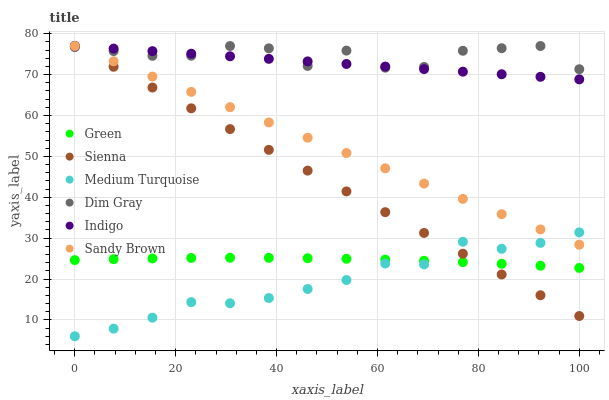Does Medium Turquoise have the minimum area under the curve?
Answer yes or no. Yes. Does Dim Gray have the maximum area under the curve?
Answer yes or no. Yes. Does Indigo have the minimum area under the curve?
Answer yes or no. No. Does Indigo have the maximum area under the curve?
Answer yes or no. No. Is Indigo the smoothest?
Answer yes or no. Yes. Is Dim Gray the roughest?
Answer yes or no. Yes. Is Sienna the smoothest?
Answer yes or no. No. Is Sienna the roughest?
Answer yes or no. No. Does Medium Turquoise have the lowest value?
Answer yes or no. Yes. Does Indigo have the lowest value?
Answer yes or no. No. Does Sandy Brown have the highest value?
Answer yes or no. Yes. Does Green have the highest value?
Answer yes or no. No. Is Medium Turquoise less than Indigo?
Answer yes or no. Yes. Is Sandy Brown greater than Green?
Answer yes or no. Yes. Does Sienna intersect Medium Turquoise?
Answer yes or no. Yes. Is Sienna less than Medium Turquoise?
Answer yes or no. No. Is Sienna greater than Medium Turquoise?
Answer yes or no. No. Does Medium Turquoise intersect Indigo?
Answer yes or no. No. 